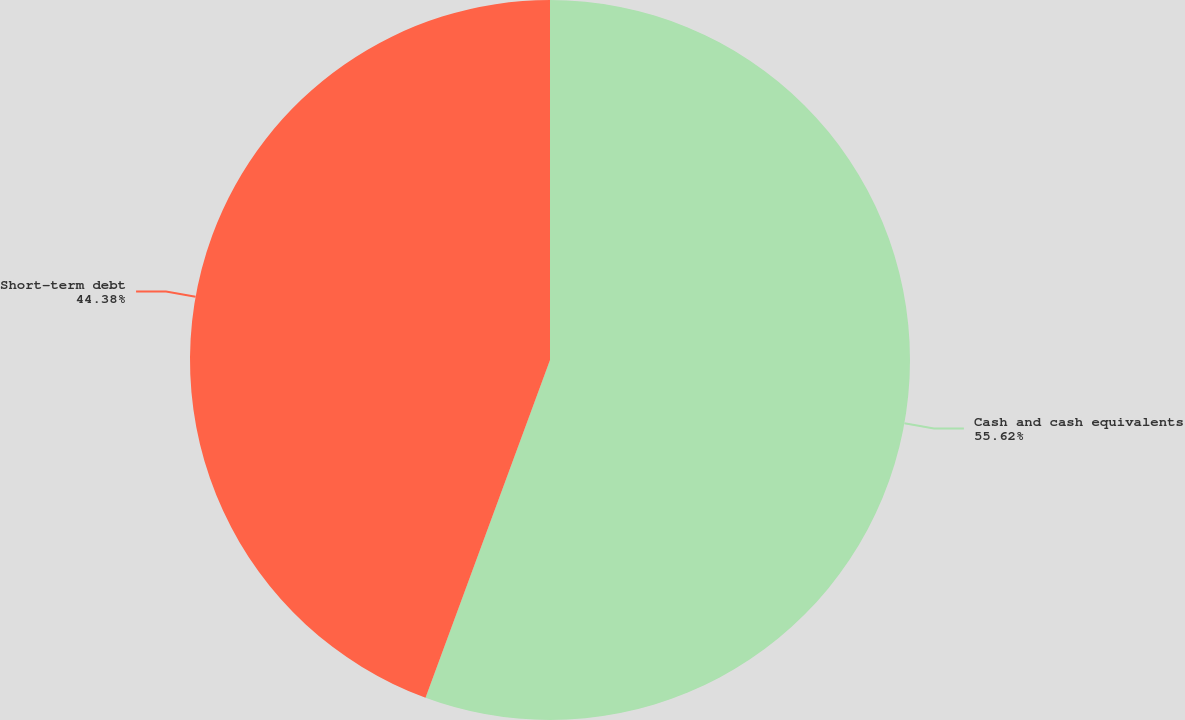Convert chart. <chart><loc_0><loc_0><loc_500><loc_500><pie_chart><fcel>Cash and cash equivalents<fcel>Short-term debt<nl><fcel>55.62%<fcel>44.38%<nl></chart> 